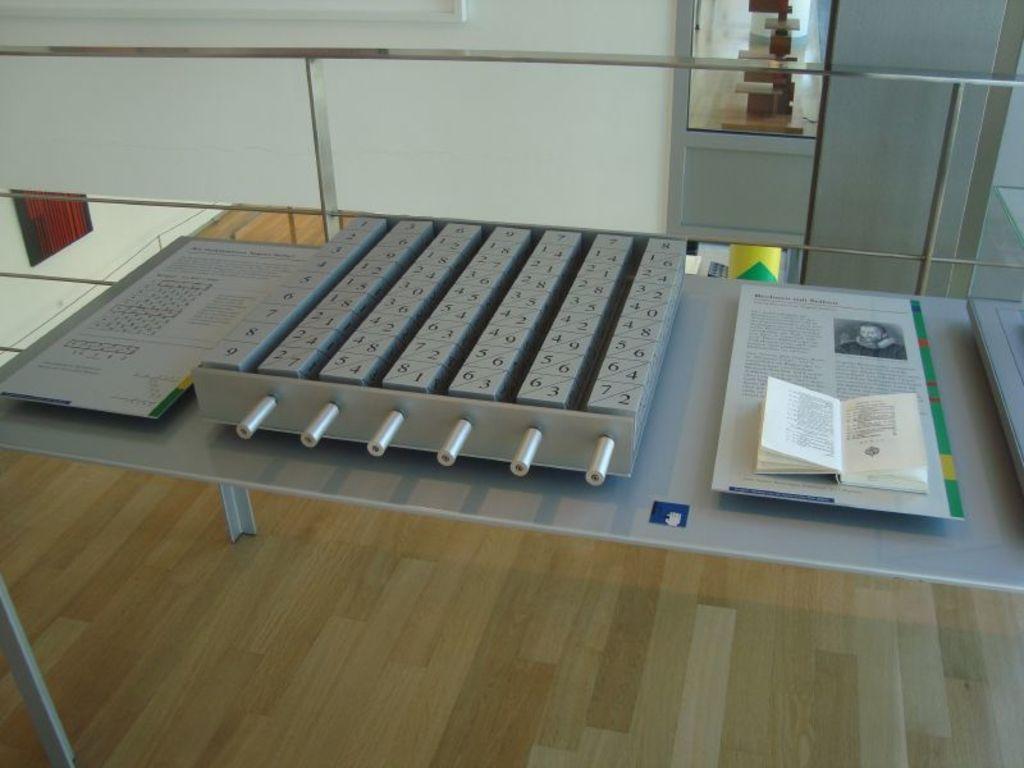Could you give a brief overview of what you see in this image? As we can see in the image there is a white color wall and table over here. On table there is a paper and book. 